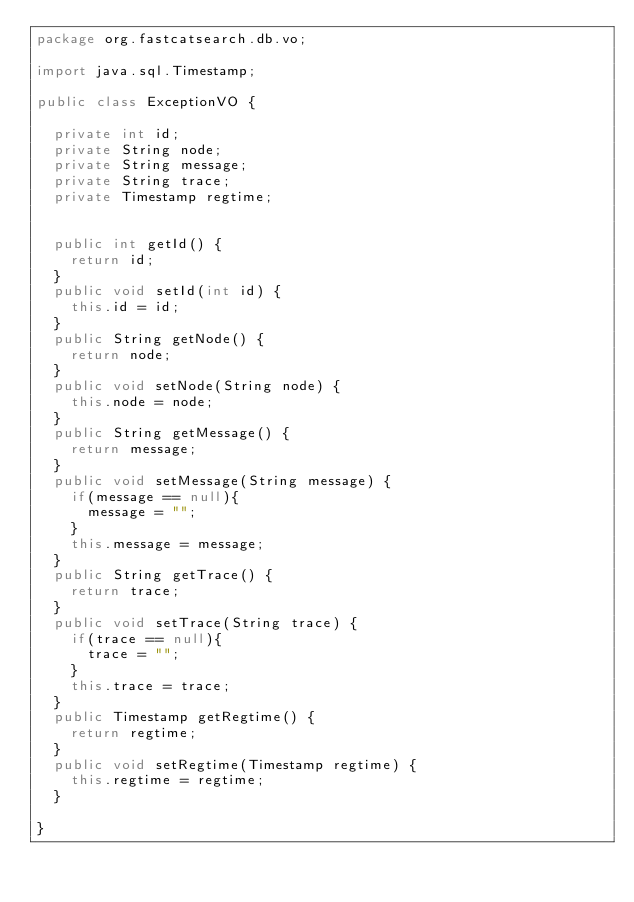<code> <loc_0><loc_0><loc_500><loc_500><_Java_>package org.fastcatsearch.db.vo;

import java.sql.Timestamp;

public class ExceptionVO {
	
	private int id;
	private String node;
	private String message;
	private String trace;
	private Timestamp regtime;
	
	
	public int getId() {
		return id;
	}
	public void setId(int id) {
		this.id = id;
	}
	public String getNode() {
		return node;
	}
	public void setNode(String node) {
		this.node = node;
	}
	public String getMessage() {
		return message;
	}
	public void setMessage(String message) {
		if(message == null){
			message = "";
		}
		this.message = message;
	}
	public String getTrace() {
		return trace;
	}
	public void setTrace(String trace) {
		if(trace == null){
			trace = "";
		}
		this.trace = trace;
	}
	public Timestamp getRegtime() {
		return regtime;
	}
	public void setRegtime(Timestamp regtime) {
		this.regtime = regtime;
	}
	
}
</code> 